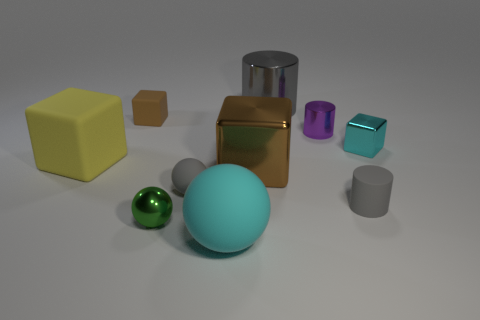There is a green metal object; is its shape the same as the thing that is in front of the small green metal object?
Offer a very short reply. Yes. Are there an equal number of small green metal objects and metal things?
Your answer should be very brief. No. Are there the same number of large yellow things to the left of the large yellow cube and tiny cylinders that are behind the tiny brown cube?
Provide a succinct answer. Yes. What number of other objects are the same material as the yellow thing?
Your answer should be very brief. 4. What number of matte things are either tiny purple cylinders or small brown things?
Offer a very short reply. 1. There is a brown thing behind the cyan block; does it have the same shape as the big brown thing?
Ensure brevity in your answer.  Yes. Are there more large brown shiny things that are in front of the small shiny ball than big things?
Your response must be concise. No. How many metallic objects are both on the right side of the tiny green metal ball and left of the big gray shiny object?
Give a very brief answer. 1. The sphere that is on the right side of the small gray matte thing left of the brown metal cube is what color?
Your answer should be compact. Cyan. How many small objects have the same color as the large ball?
Provide a succinct answer. 1. 